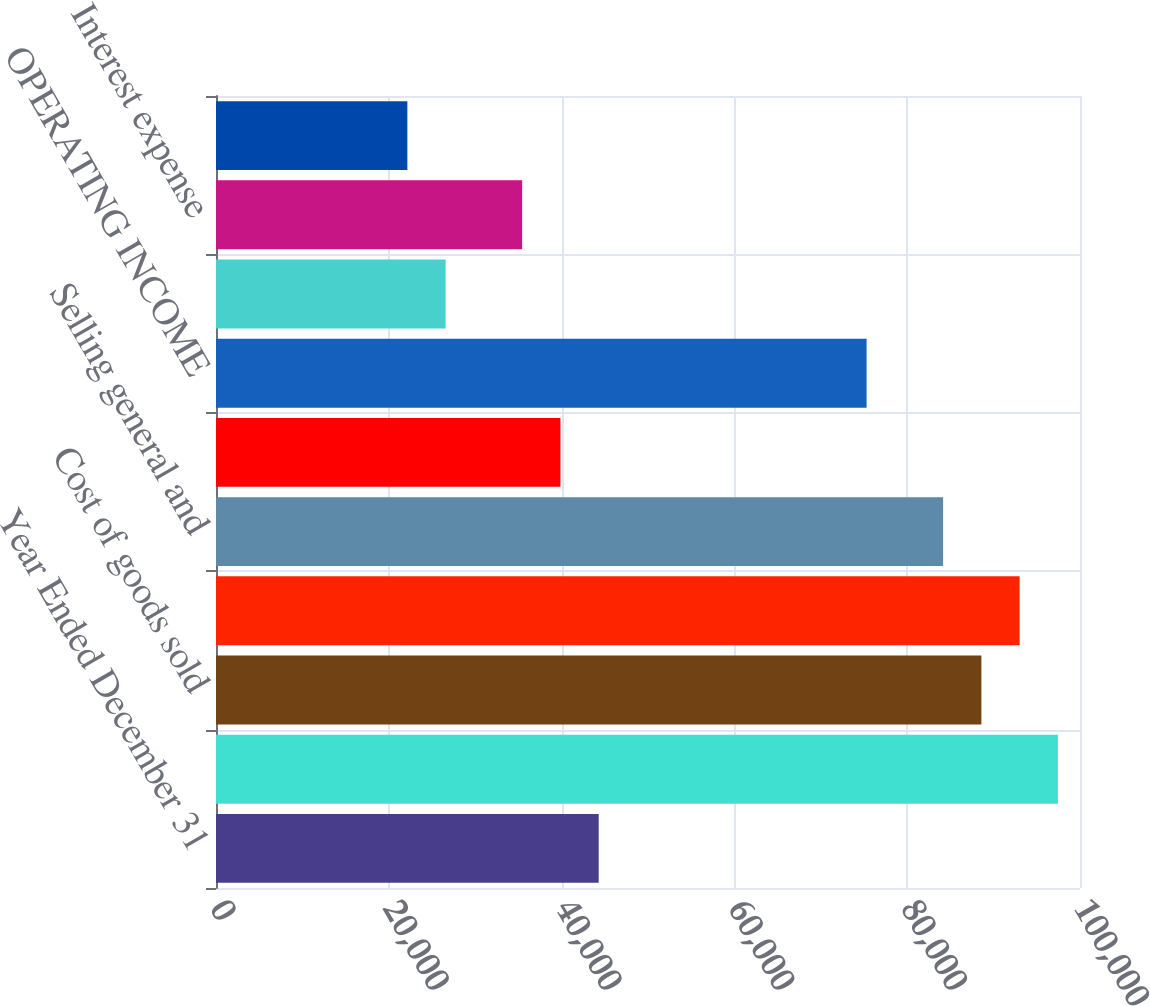<chart> <loc_0><loc_0><loc_500><loc_500><bar_chart><fcel>Year Ended December 31<fcel>NET OPERATING REVENUES<fcel>Cost of goods sold<fcel>GROSS PROFIT<fcel>Selling general and<fcel>Other operating charges<fcel>OPERATING INCOME<fcel>Interest income<fcel>Interest expense<fcel>Equity income (loss) - net<nl><fcel>44294<fcel>97444.7<fcel>88586.3<fcel>93015.5<fcel>84157<fcel>39864.7<fcel>75298.6<fcel>26577<fcel>35435.5<fcel>22147.8<nl></chart> 